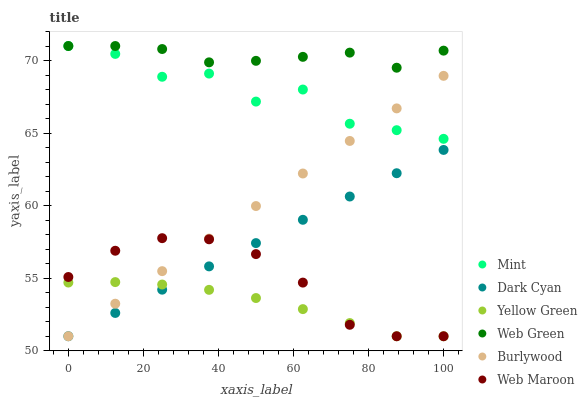Does Yellow Green have the minimum area under the curve?
Answer yes or no. Yes. Does Web Green have the maximum area under the curve?
Answer yes or no. Yes. Does Burlywood have the minimum area under the curve?
Answer yes or no. No. Does Burlywood have the maximum area under the curve?
Answer yes or no. No. Is Burlywood the smoothest?
Answer yes or no. Yes. Is Mint the roughest?
Answer yes or no. Yes. Is Web Maroon the smoothest?
Answer yes or no. No. Is Web Maroon the roughest?
Answer yes or no. No. Does Yellow Green have the lowest value?
Answer yes or no. Yes. Does Web Green have the lowest value?
Answer yes or no. No. Does Mint have the highest value?
Answer yes or no. Yes. Does Burlywood have the highest value?
Answer yes or no. No. Is Yellow Green less than Web Green?
Answer yes or no. Yes. Is Web Green greater than Dark Cyan?
Answer yes or no. Yes. Does Web Green intersect Mint?
Answer yes or no. Yes. Is Web Green less than Mint?
Answer yes or no. No. Is Web Green greater than Mint?
Answer yes or no. No. Does Yellow Green intersect Web Green?
Answer yes or no. No. 